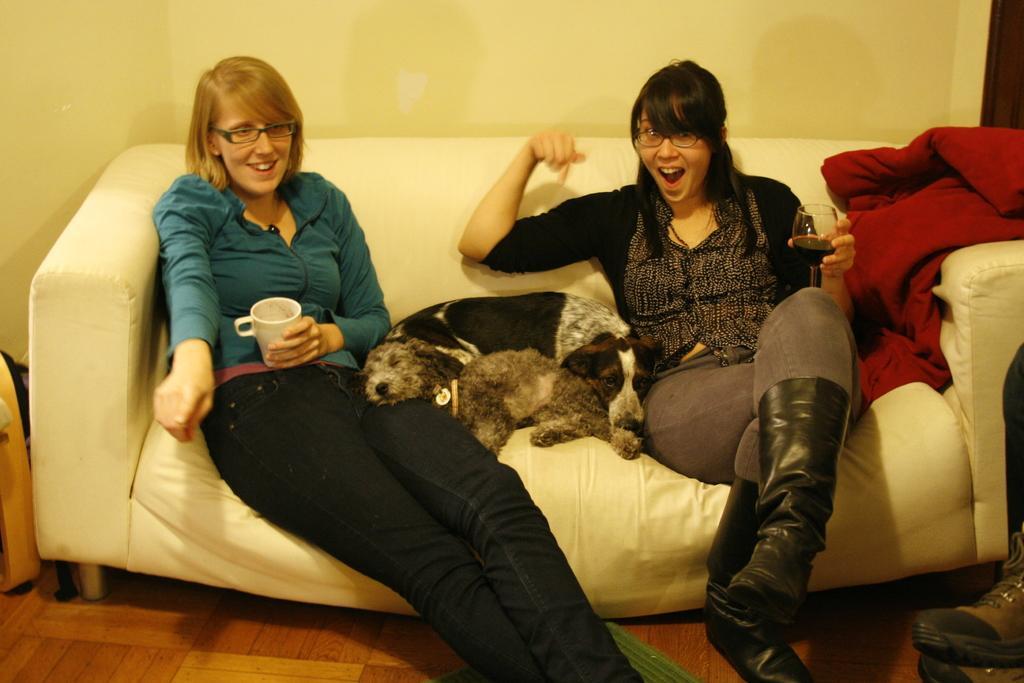In one or two sentences, can you explain what this image depicts? In this picture we can see two women wore spectacles holding cup and glass in their hands and in between them we can see dog they are on sofa and in background we can see wall. 